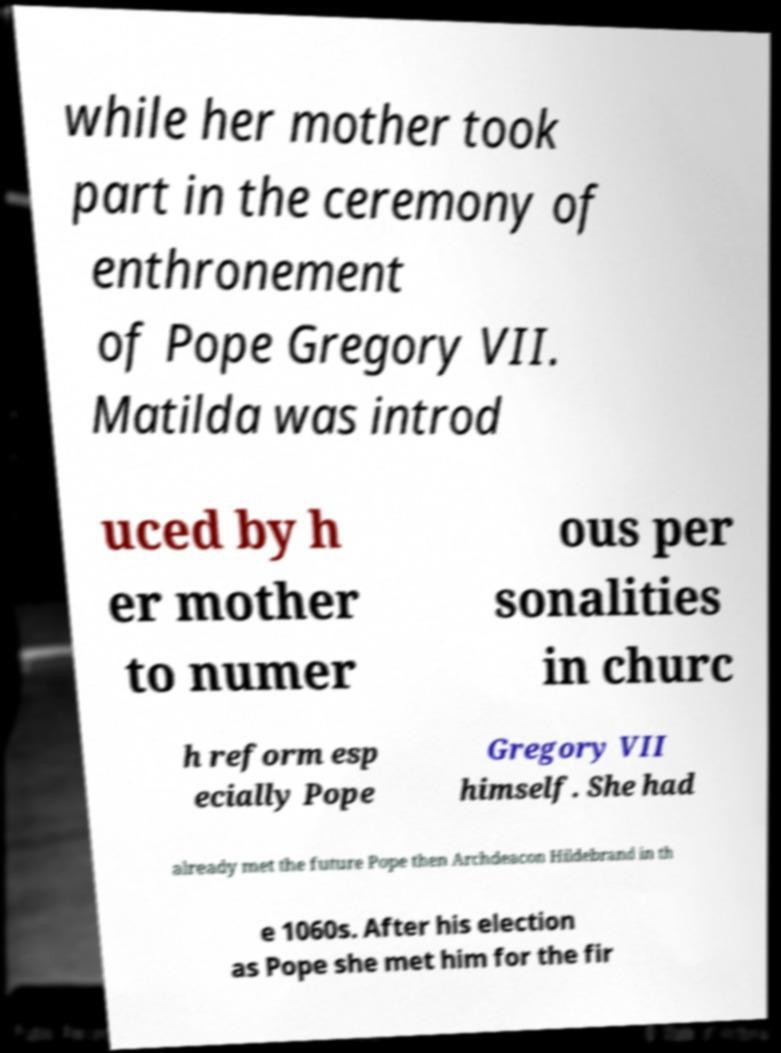For documentation purposes, I need the text within this image transcribed. Could you provide that? while her mother took part in the ceremony of enthronement of Pope Gregory VII. Matilda was introd uced by h er mother to numer ous per sonalities in churc h reform esp ecially Pope Gregory VII himself. She had already met the future Pope then Archdeacon Hildebrand in th e 1060s. After his election as Pope she met him for the fir 